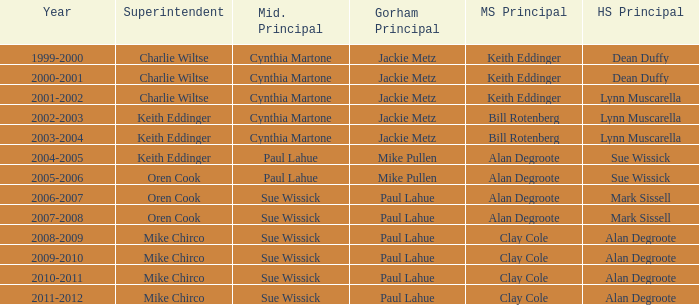How many years was lynn muscarella the high school principal and charlie wiltse the superintendent? 1.0. 